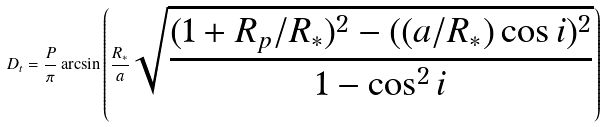<formula> <loc_0><loc_0><loc_500><loc_500>D _ { t } = \frac { P } { \pi } \arcsin { \left ( \frac { R _ { * } } { a } \sqrt { \frac { ( 1 + R _ { p } / R _ { * } ) ^ { 2 } - ( ( a / R _ { * } ) \cos i ) ^ { 2 } } { 1 - \cos ^ { 2 } i } } \right ) }</formula> 